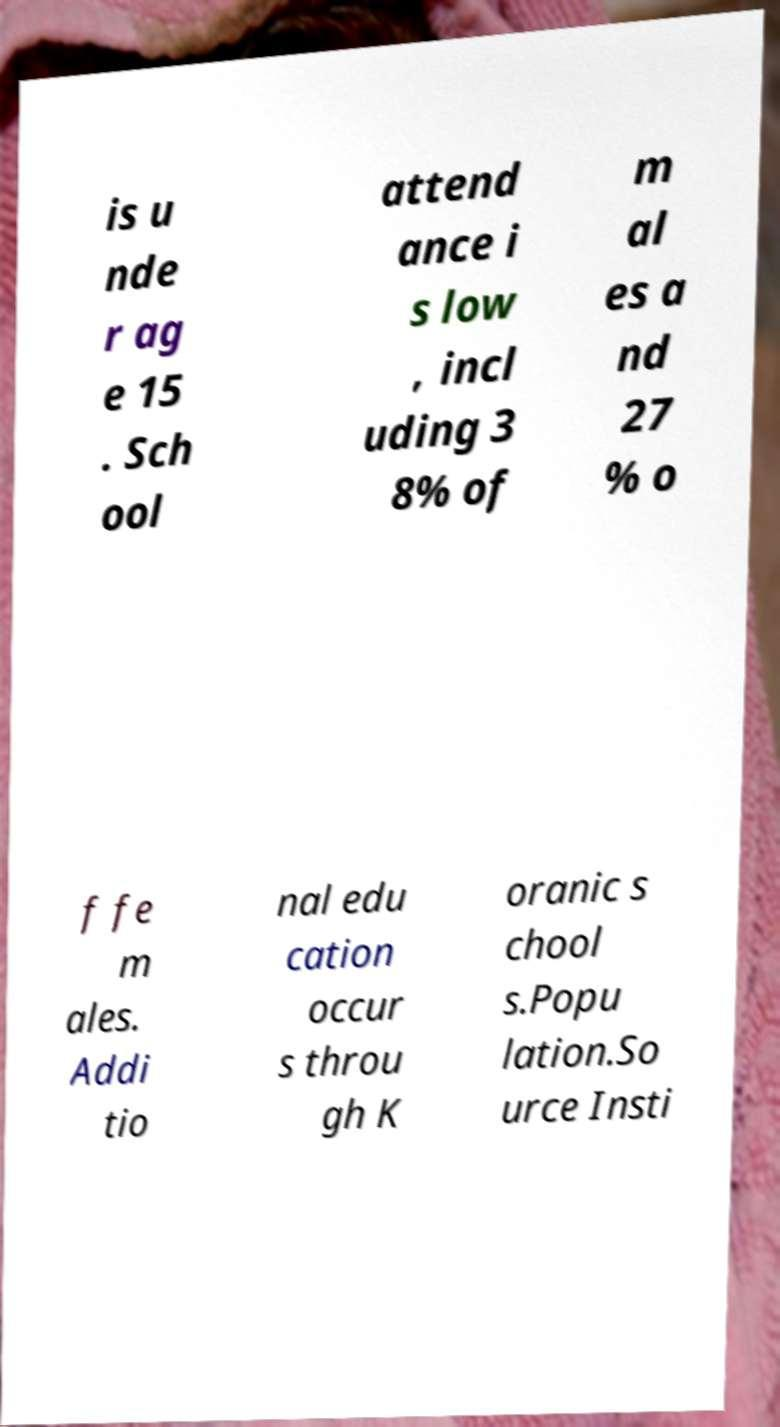I need the written content from this picture converted into text. Can you do that? is u nde r ag e 15 . Sch ool attend ance i s low , incl uding 3 8% of m al es a nd 27 % o f fe m ales. Addi tio nal edu cation occur s throu gh K oranic s chool s.Popu lation.So urce Insti 